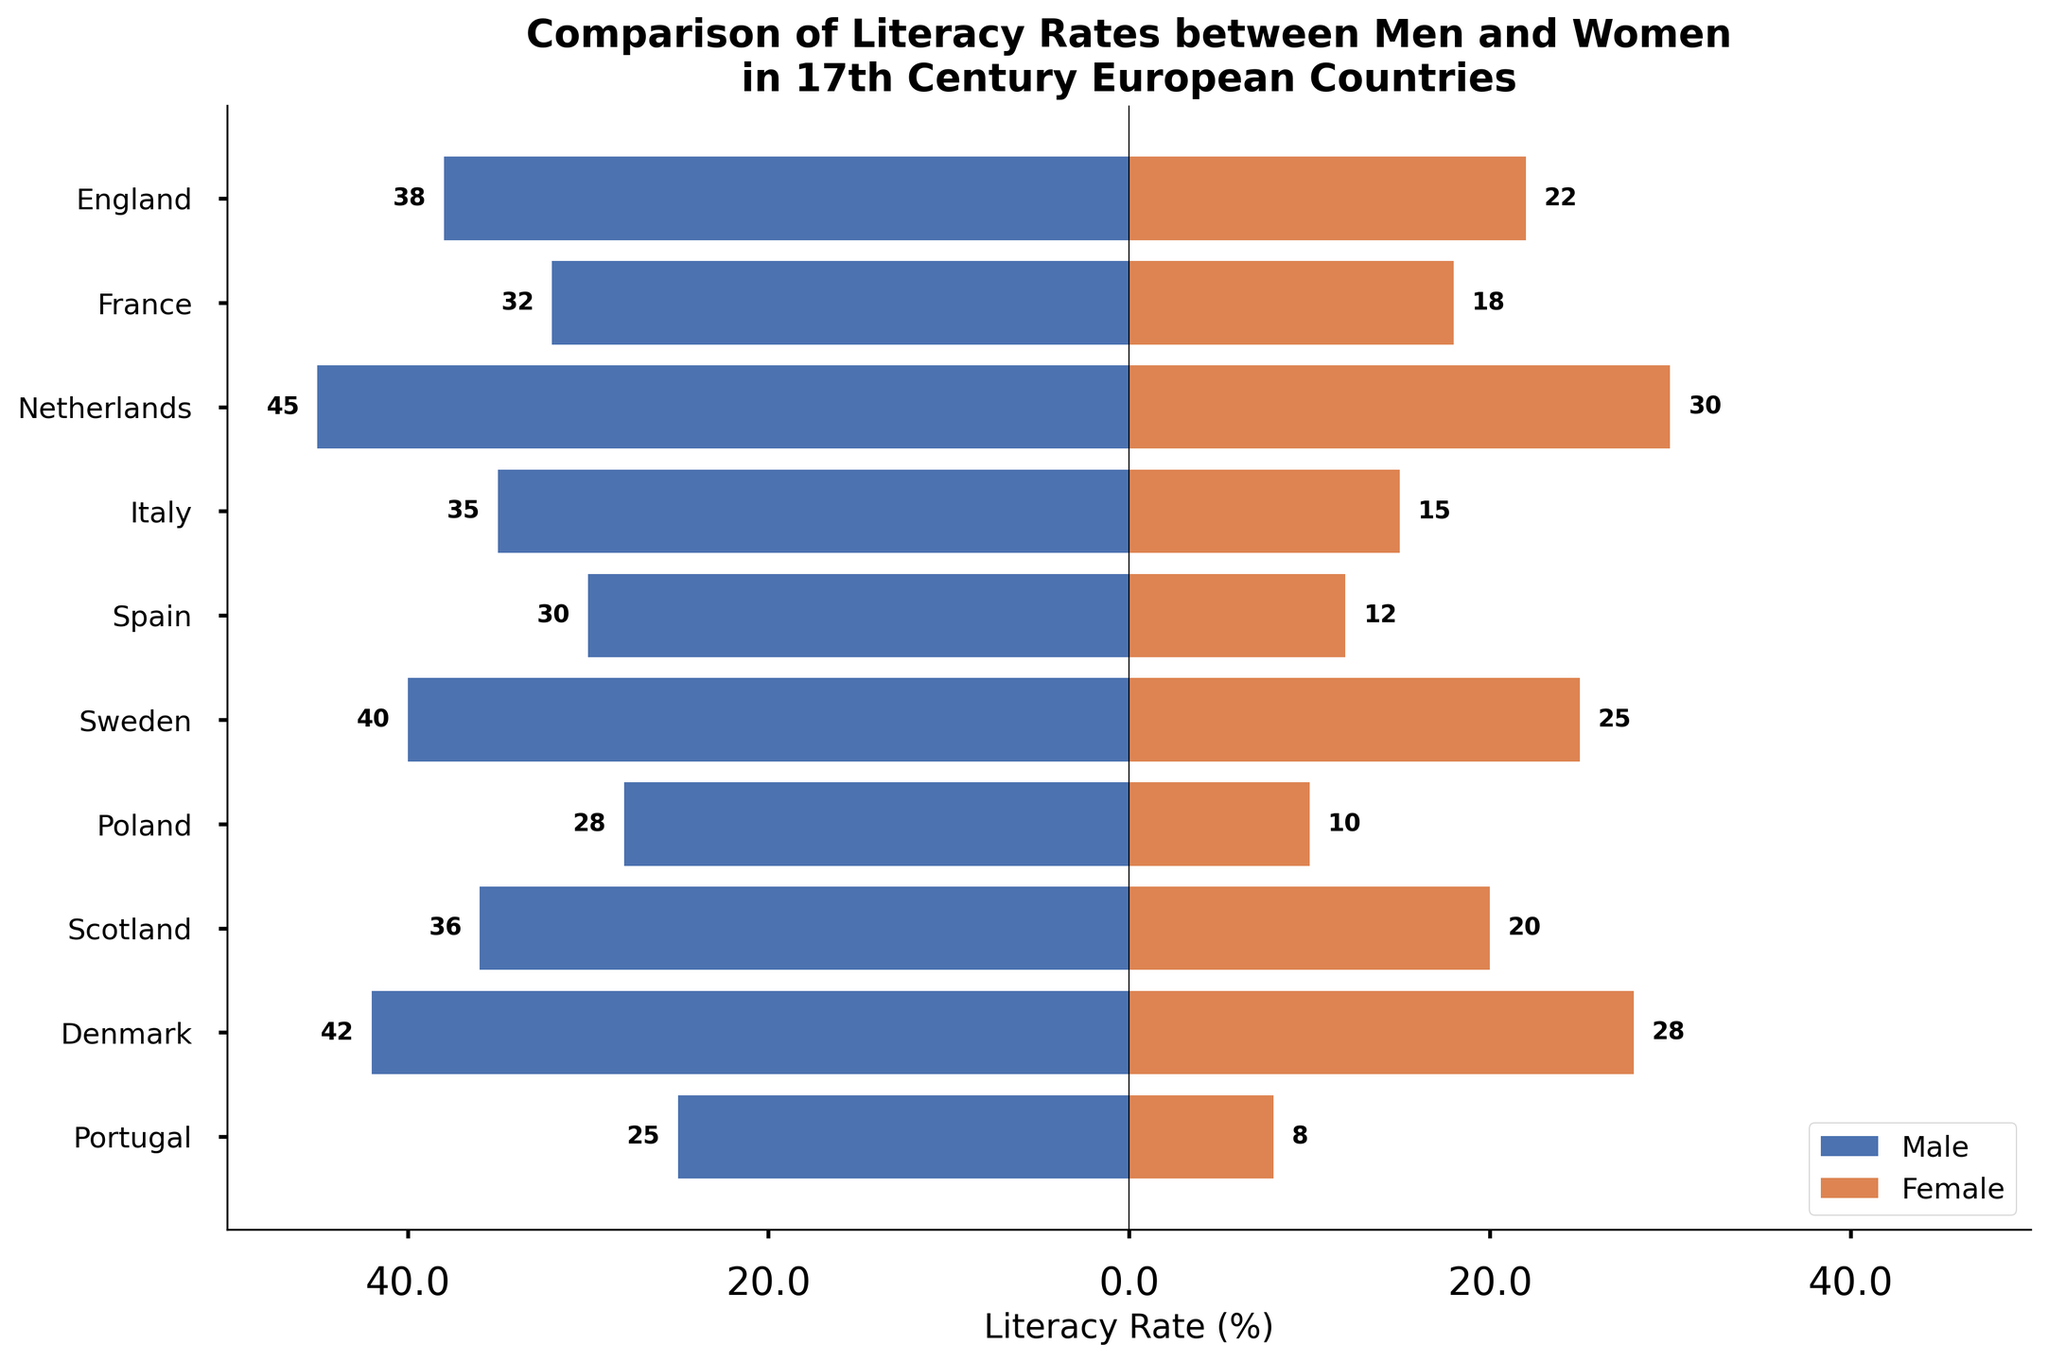What is the title of the figure? The title usually appears at the top of the figure and directly states the main subject of the visualization. The title here is clearly stated on top of the population pyramid chart.
Answer: Comparison of Literacy Rates between Men and Women in 17th Century European Countries How many countries are represented in this figure? Each bar in the population pyramid represents a country; counting all the bars gives the number of countries.
Answer: 10 Which country has the highest female literacy rate? To find the country with the highest female literacy rate, look at the length of the red bars (representing female literacy rates) and identify the longest one.
Answer: Netherlands Which country has the largest gender gap in literacy rate? Calculate the difference between male and female literacy rates for each country, then compare these differences to identify the largest one. For Poland, (28 - 10) = 18 percentage points, which is the largest gap.
Answer: Poland What is the average male literacy rate across all the countries? Sum the male literacy rates of all countries and divide by the number of countries: (38+32+45+35+30+40+28+36+42+25) / 10 = 35.1.
Answer: 35.1 Which countries have a male literacy rate greater than 40%? Compare each country’s male literacy rate to 40%. If it is greater than 40%, list those countries. The countries with male literacy rates greater than 40% are Netherlands and Denmark (45% and 42%).
Answer: Netherlands, Denmark Compare the literacy rates of men in England and Spain. Which country has a higher rate? Check the bars corresponding to England and Spain for male literacy rates. England’s rate is higher at 38% compared to Spain's 30%.
Answer: England Which country has the lowest female literacy rate? Check the end points of the red bars representing female literacy rates and identify the shortest one.
Answer: Portugal How does the literacy rate of women in Italy compare to that in Scotland? Compare the lengths of the red bars for Italy and Scotland. Italy has a rate of 15% while Scotland has 20%.
Answer: Scotland is higher What is the median male literacy rate for the countries depicted? List the male literacy rates: {25, 28, 30, 32, 35, 36, 38, 40, 42, 45}, and find the middle value. For 10 values, median is the average of 5th and 6th: (35 + 36) / 2 = 35.5.
Answer: 35.5 